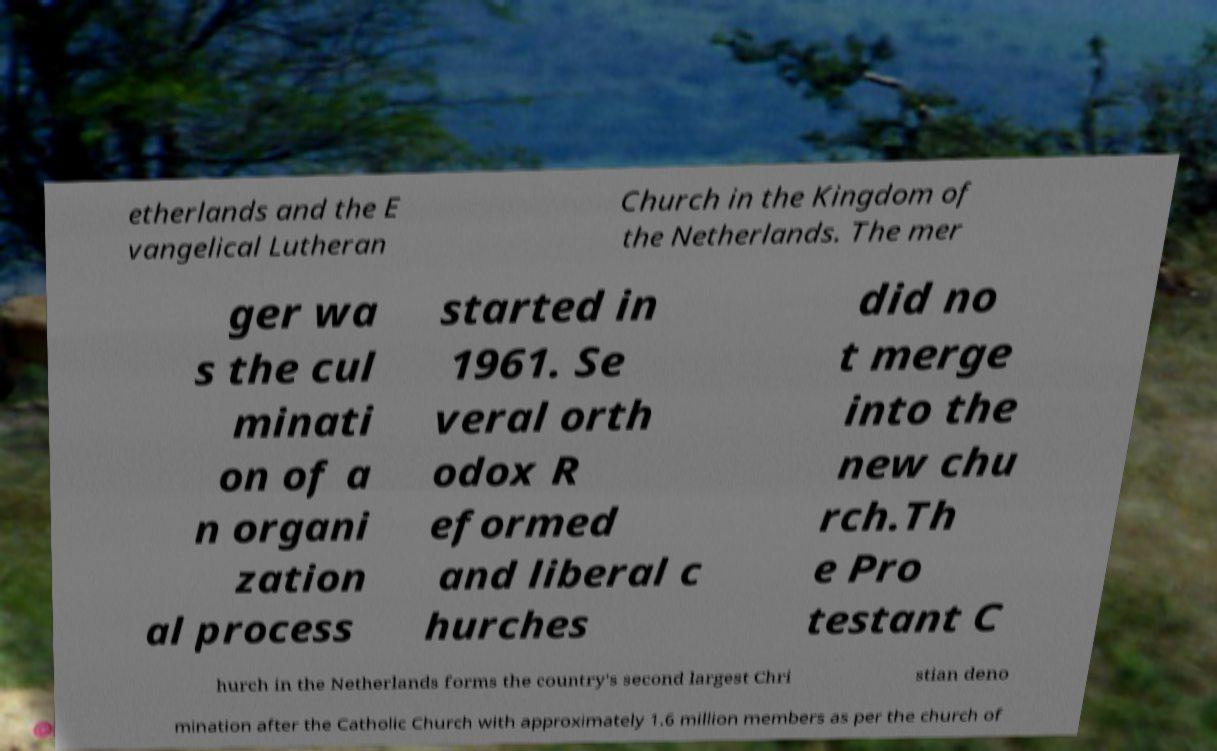Can you read and provide the text displayed in the image?This photo seems to have some interesting text. Can you extract and type it out for me? etherlands and the E vangelical Lutheran Church in the Kingdom of the Netherlands. The mer ger wa s the cul minati on of a n organi zation al process started in 1961. Se veral orth odox R eformed and liberal c hurches did no t merge into the new chu rch.Th e Pro testant C hurch in the Netherlands forms the country's second largest Chri stian deno mination after the Catholic Church with approximately 1.6 million members as per the church of 